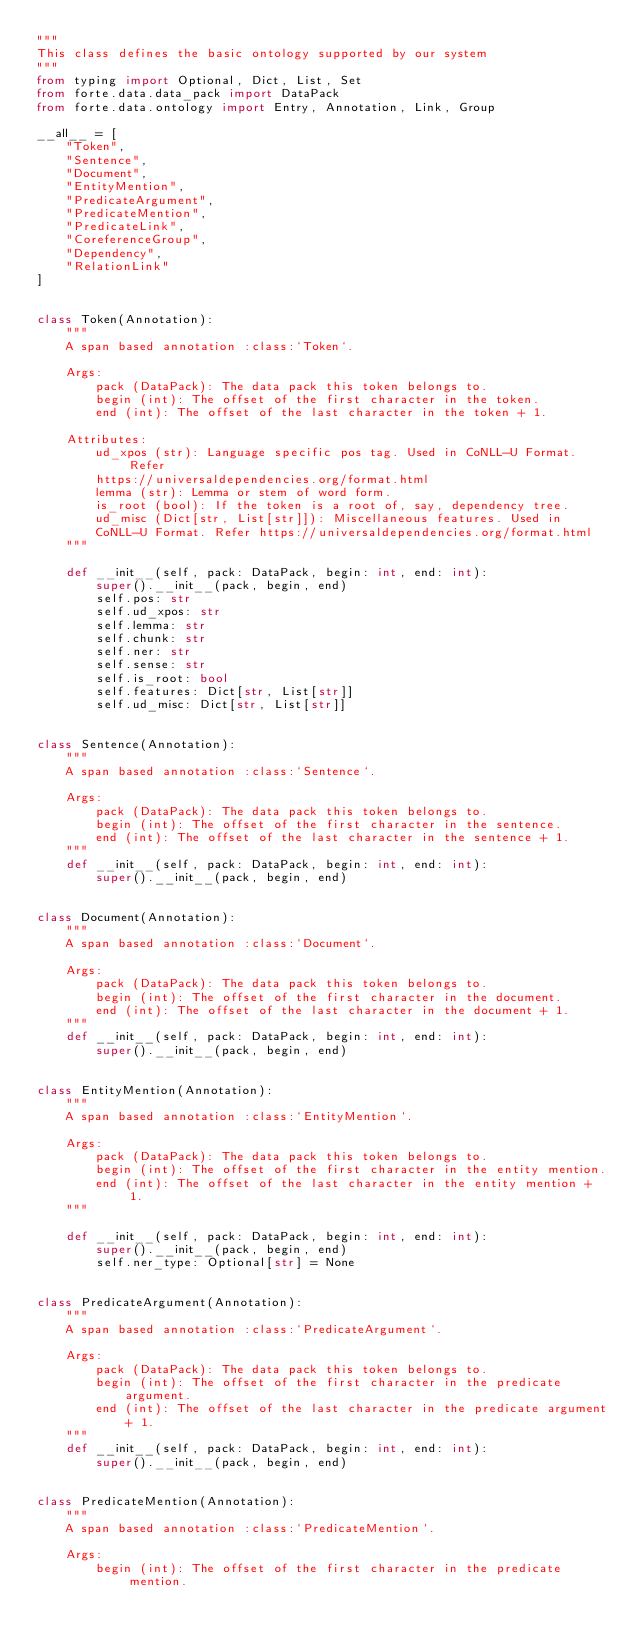Convert code to text. <code><loc_0><loc_0><loc_500><loc_500><_Python_>"""
This class defines the basic ontology supported by our system
"""
from typing import Optional, Dict, List, Set
from forte.data.data_pack import DataPack
from forte.data.ontology import Entry, Annotation, Link, Group

__all__ = [
    "Token",
    "Sentence",
    "Document",
    "EntityMention",
    "PredicateArgument",
    "PredicateMention",
    "PredicateLink",
    "CoreferenceGroup",
    "Dependency",
    "RelationLink"
]


class Token(Annotation):
    """
    A span based annotation :class:`Token`.

    Args:
        pack (DataPack): The data pack this token belongs to.
        begin (int): The offset of the first character in the token.
        end (int): The offset of the last character in the token + 1.

    Attributes:
        ud_xpos (str): Language specific pos tag. Used in CoNLL-U Format. Refer
        https://universaldependencies.org/format.html
        lemma (str): Lemma or stem of word form.
        is_root (bool): If the token is a root of, say, dependency tree.
        ud_misc (Dict[str, List[str]]): Miscellaneous features. Used in
        CoNLL-U Format. Refer https://universaldependencies.org/format.html
    """

    def __init__(self, pack: DataPack, begin: int, end: int):
        super().__init__(pack, begin, end)
        self.pos: str
        self.ud_xpos: str
        self.lemma: str
        self.chunk: str
        self.ner: str
        self.sense: str
        self.is_root: bool
        self.features: Dict[str, List[str]]
        self.ud_misc: Dict[str, List[str]]


class Sentence(Annotation):
    """
    A span based annotation :class:`Sentence`.

    Args:
        pack (DataPack): The data pack this token belongs to.
        begin (int): The offset of the first character in the sentence.
        end (int): The offset of the last character in the sentence + 1.
    """
    def __init__(self, pack: DataPack, begin: int, end: int):
        super().__init__(pack, begin, end)


class Document(Annotation):
    """
    A span based annotation :class:`Document`.

    Args:
        pack (DataPack): The data pack this token belongs to.
        begin (int): The offset of the first character in the document.
        end (int): The offset of the last character in the document + 1.
    """
    def __init__(self, pack: DataPack, begin: int, end: int):
        super().__init__(pack, begin, end)


class EntityMention(Annotation):
    """
    A span based annotation :class:`EntityMention`.

    Args:
        pack (DataPack): The data pack this token belongs to.
        begin (int): The offset of the first character in the entity mention.
        end (int): The offset of the last character in the entity mention + 1.
    """

    def __init__(self, pack: DataPack, begin: int, end: int):
        super().__init__(pack, begin, end)
        self.ner_type: Optional[str] = None


class PredicateArgument(Annotation):
    """
    A span based annotation :class:`PredicateArgument`.

    Args:
        pack (DataPack): The data pack this token belongs to.
        begin (int): The offset of the first character in the predicate
            argument.
        end (int): The offset of the last character in the predicate argument
            + 1.
    """
    def __init__(self, pack: DataPack, begin: int, end: int):
        super().__init__(pack, begin, end)


class PredicateMention(Annotation):
    """
    A span based annotation :class:`PredicateMention`.

    Args:
        begin (int): The offset of the first character in the predicate mention.</code> 